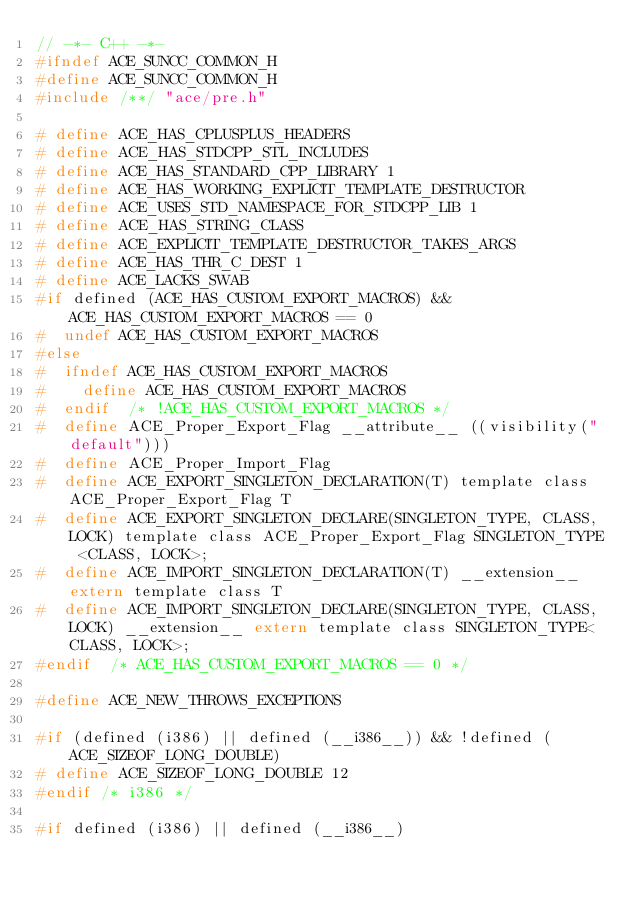Convert code to text. <code><loc_0><loc_0><loc_500><loc_500><_C_>// -*- C++ -*-
#ifndef ACE_SUNCC_COMMON_H
#define ACE_SUNCC_COMMON_H
#include /**/ "ace/pre.h"

# define ACE_HAS_CPLUSPLUS_HEADERS
# define ACE_HAS_STDCPP_STL_INCLUDES
# define ACE_HAS_STANDARD_CPP_LIBRARY 1
# define ACE_HAS_WORKING_EXPLICIT_TEMPLATE_DESTRUCTOR
# define ACE_USES_STD_NAMESPACE_FOR_STDCPP_LIB 1
# define ACE_HAS_STRING_CLASS
# define ACE_EXPLICIT_TEMPLATE_DESTRUCTOR_TAKES_ARGS
# define ACE_HAS_THR_C_DEST 1
# define ACE_LACKS_SWAB
#if defined (ACE_HAS_CUSTOM_EXPORT_MACROS) && ACE_HAS_CUSTOM_EXPORT_MACROS == 0
#  undef ACE_HAS_CUSTOM_EXPORT_MACROS
#else
#  ifndef ACE_HAS_CUSTOM_EXPORT_MACROS
#    define ACE_HAS_CUSTOM_EXPORT_MACROS
#  endif  /* !ACE_HAS_CUSTOM_EXPORT_MACROS */
#  define ACE_Proper_Export_Flag __attribute__ ((visibility("default")))
#  define ACE_Proper_Import_Flag
#  define ACE_EXPORT_SINGLETON_DECLARATION(T) template class ACE_Proper_Export_Flag T
#  define ACE_EXPORT_SINGLETON_DECLARE(SINGLETON_TYPE, CLASS, LOCK) template class ACE_Proper_Export_Flag SINGLETON_TYPE <CLASS, LOCK>;
#  define ACE_IMPORT_SINGLETON_DECLARATION(T) __extension__ extern template class T
#  define ACE_IMPORT_SINGLETON_DECLARE(SINGLETON_TYPE, CLASS, LOCK) __extension__ extern template class SINGLETON_TYPE<CLASS, LOCK>;
#endif  /* ACE_HAS_CUSTOM_EXPORT_MACROS == 0 */

#define ACE_NEW_THROWS_EXCEPTIONS

#if (defined (i386) || defined (__i386__)) && !defined (ACE_SIZEOF_LONG_DOUBLE)
# define ACE_SIZEOF_LONG_DOUBLE 12
#endif /* i386 */

#if defined (i386) || defined (__i386__)</code> 